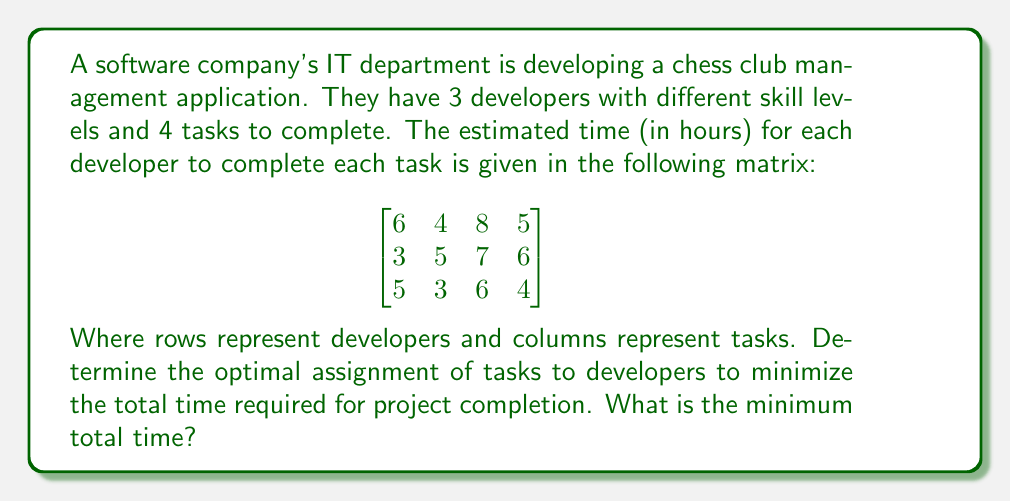Teach me how to tackle this problem. This problem can be solved using the Hungarian Algorithm for assignment optimization. Here's a step-by-step solution:

1. Step 1: Subtract the smallest element in each row from all elements in that row.

$$
\begin{bmatrix}
2 & 0 & 4 & 1 \\
0 & 2 & 4 & 3 \\
2 & 0 & 3 & 1
\end{bmatrix}
$$

2. Step 2: Subtract the smallest element in each column from all elements in that column.

$$
\begin{bmatrix}
2 & 0 & 1 & 0 \\
0 & 2 & 1 & 2 \\
2 & 0 & 0 & 0
\end{bmatrix}
$$

3. Step 3: Draw lines through rows and columns to cover all zeros using the minimum number of lines.

[asy]
unitsize(1cm);
draw((0,0)--(4,0)--(4,3)--(0,3)--cycle);
for(int i=1; i<4; ++i) {
  draw((0,i)--(4,i));
}
for(int j=1; j<4; ++j) {
  draw((j,0)--(j,3));
}
draw((0,0.5)--(4,0.5),red+1);
draw((0.5,0)--(0.5,3),red+1);
draw((3.5,0)--(3.5,3),red+1);
[/asy]

4. Step 4: Since the number of lines (3) is equal to the number of rows/columns, we have an optimal solution. If not, we would need to create additional zeros and repeat steps 3-4.

5. Step 5: Select zeros, one in each row and column:

   Developer 1 -> Task 2
   Developer 2 -> Task 1
   Developer 3 -> Task 4

6. Step 6: Map these assignments back to the original matrix to find the total time:

   Developer 1 (Task 2): 4 hours
   Developer 2 (Task 1): 3 hours
   Developer 3 (Task 4): 4 hours

7. Sum up the times to get the total minimum time: 4 + 3 + 4 = 11 hours
Answer: The optimal assignment of tasks to developers is:
Developer 1 -> Task 2
Developer 2 -> Task 1
Developer 3 -> Task 4

The minimum total time required for project completion is 11 hours. 